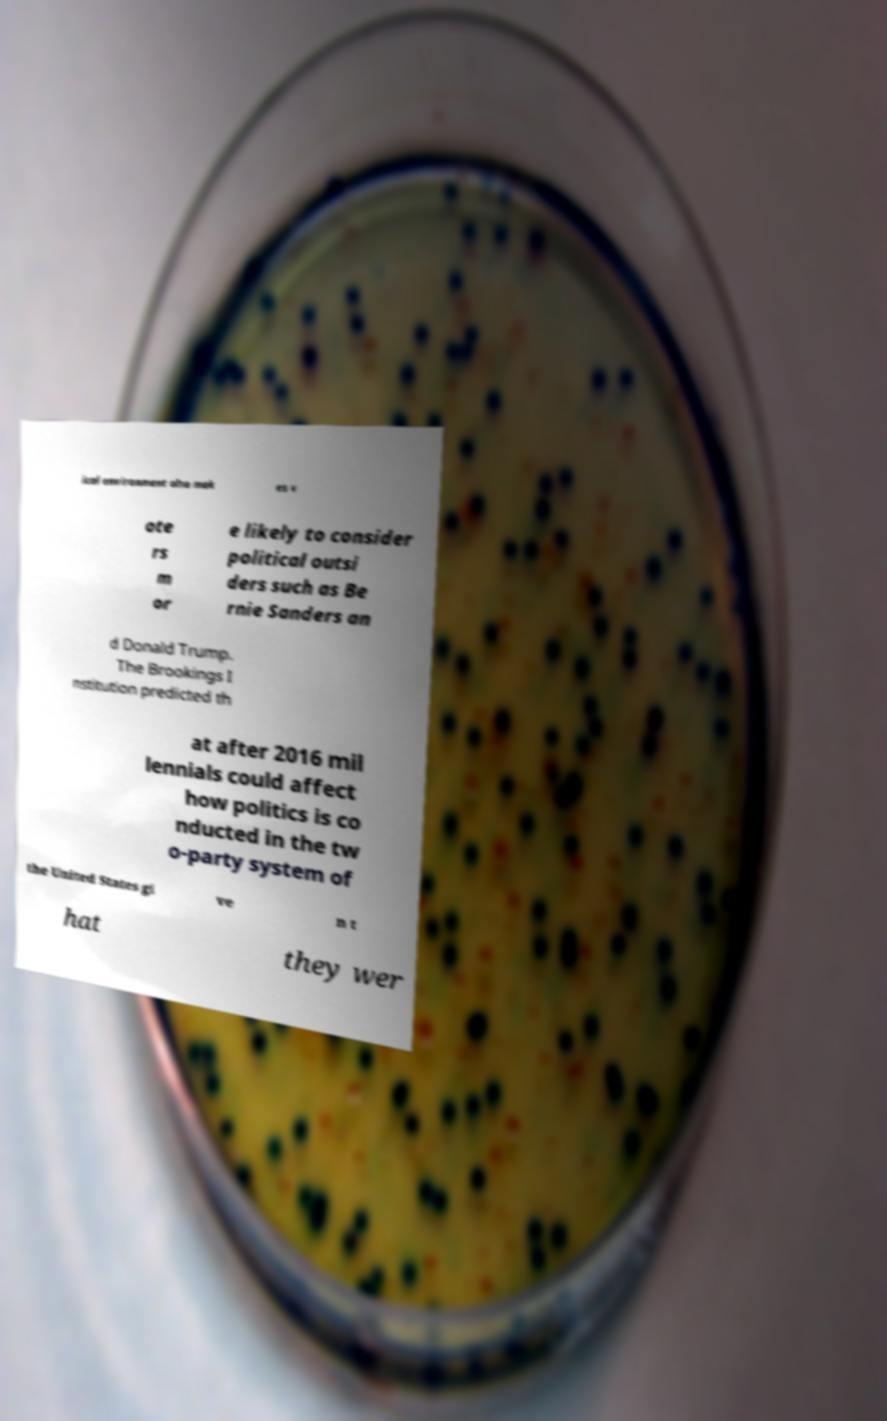What messages or text are displayed in this image? I need them in a readable, typed format. ical environment also mak es v ote rs m or e likely to consider political outsi ders such as Be rnie Sanders an d Donald Trump. The Brookings I nstitution predicted th at after 2016 mil lennials could affect how politics is co nducted in the tw o-party system of the United States gi ve n t hat they wer 